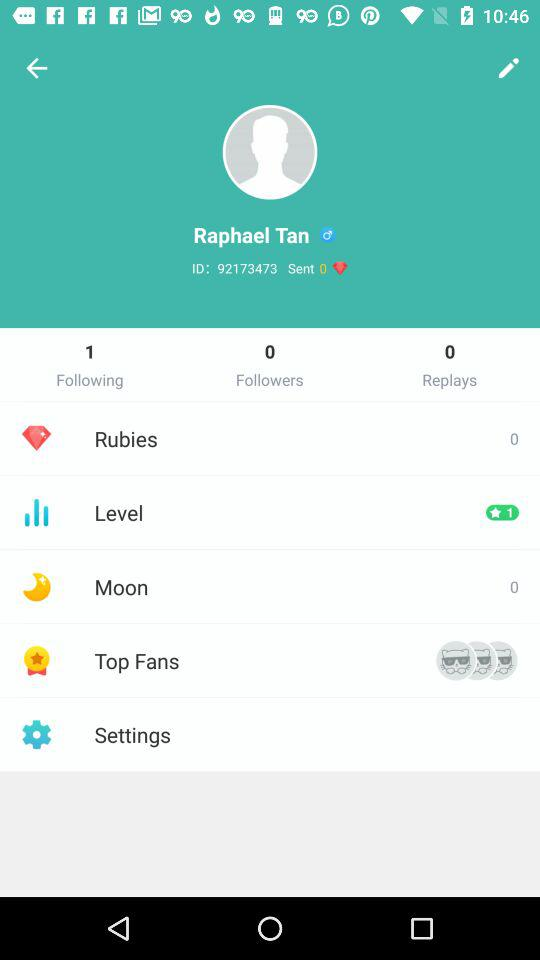What is the ID of the user? The ID of the user is 92173473. 